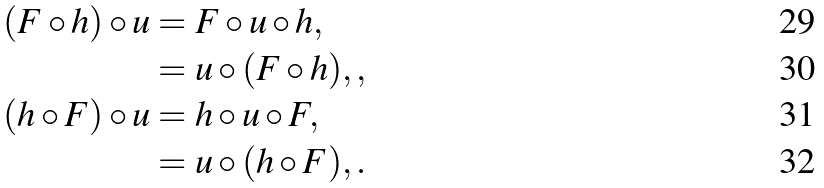<formula> <loc_0><loc_0><loc_500><loc_500>( F \circ h ) \circ u & = F \circ u \circ h , \\ & = u \circ ( F \circ h ) , , \\ ( h \circ F ) \circ u & = h \circ u \circ F , \\ & = u \circ ( h \circ F ) , .</formula> 